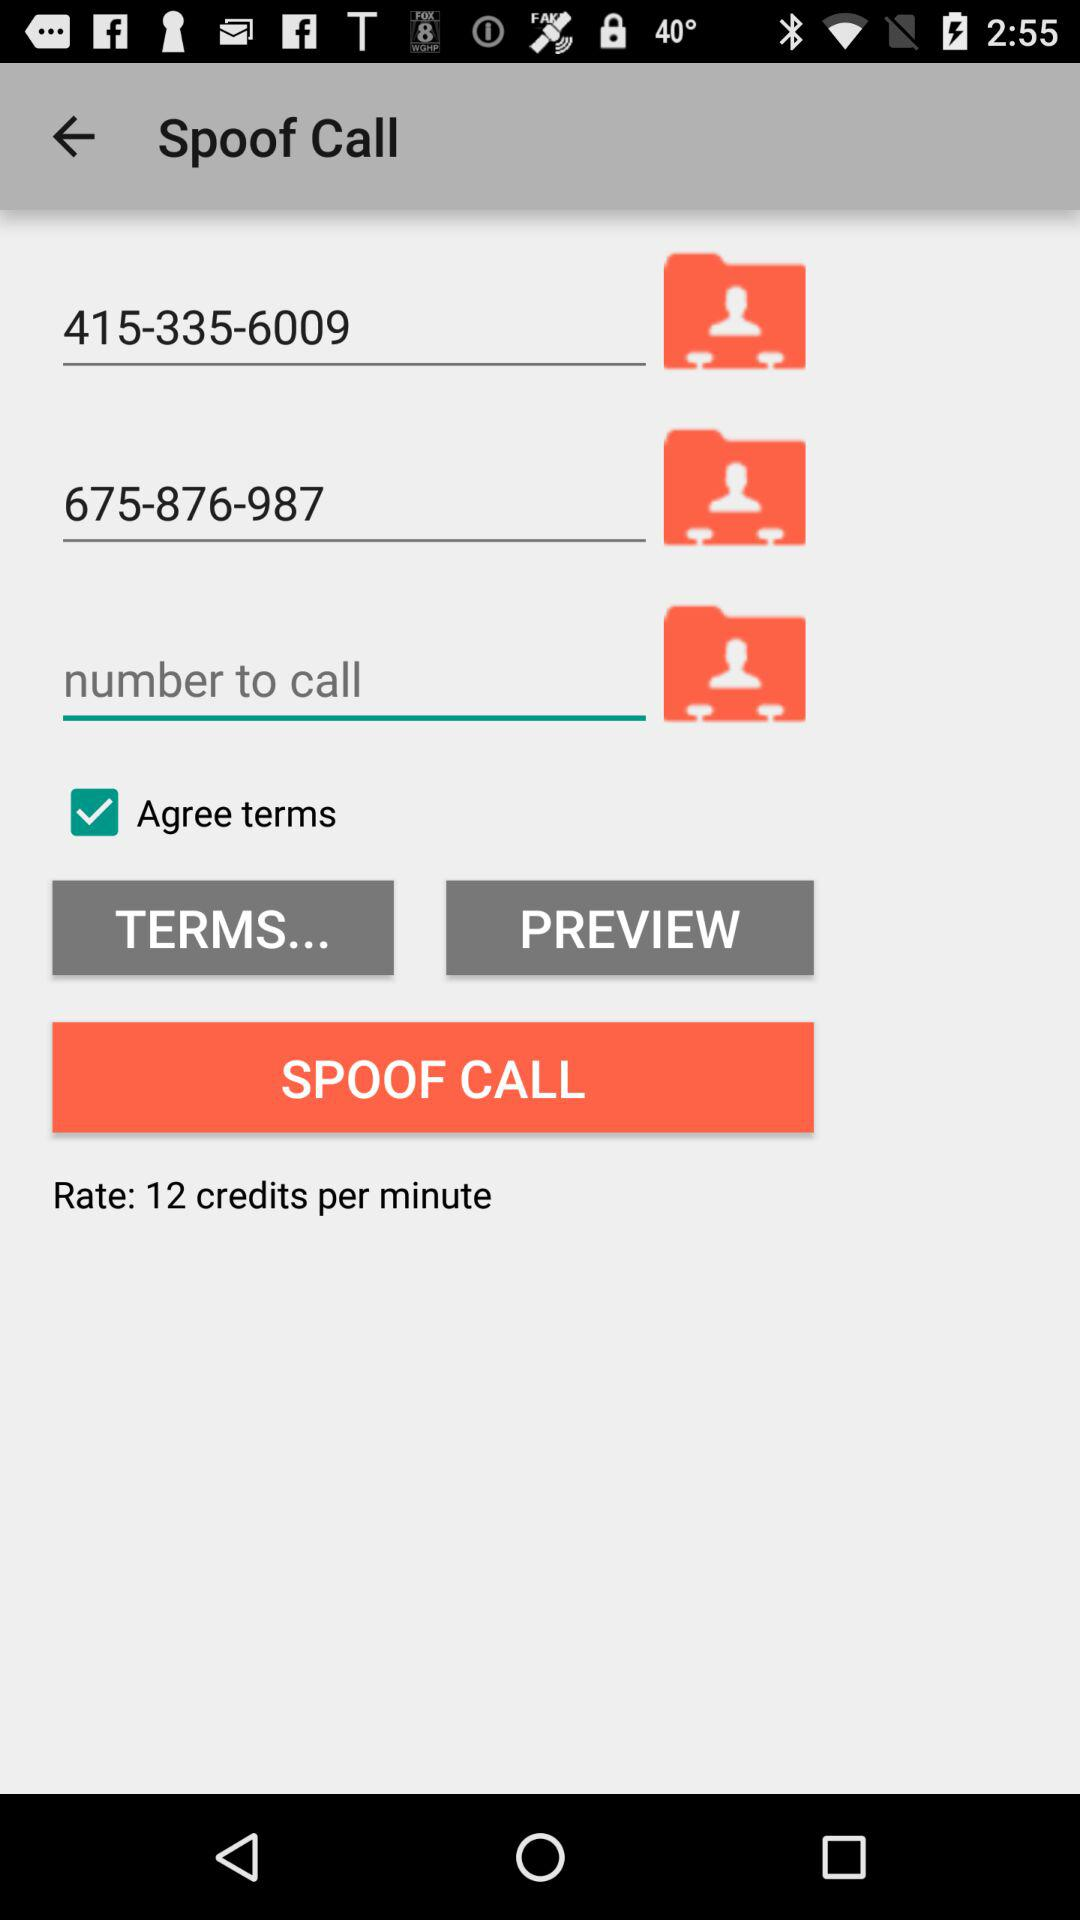What is the status of "Agree terms"? The status is "on". 